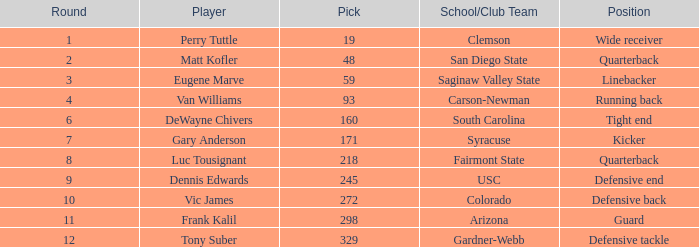Which Round has a School/Club Team of arizona, and a Pick smaller than 298? None. 